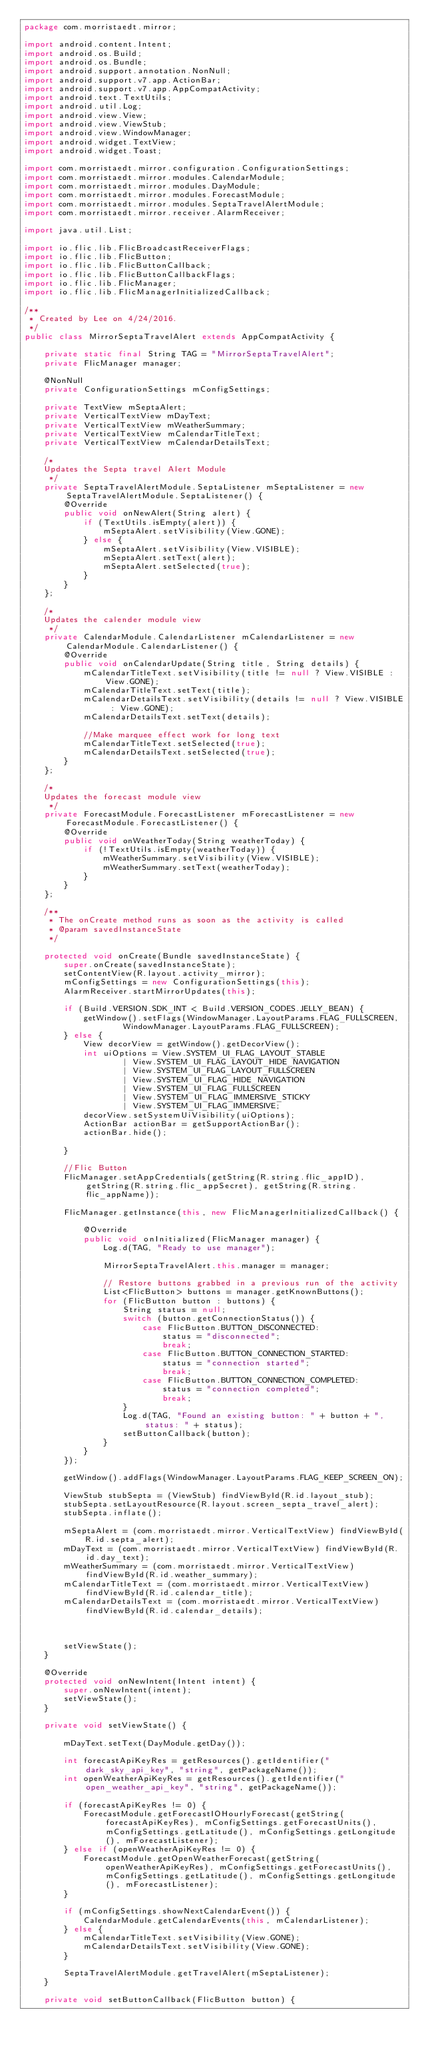Convert code to text. <code><loc_0><loc_0><loc_500><loc_500><_Java_>package com.morristaedt.mirror;

import android.content.Intent;
import android.os.Build;
import android.os.Bundle;
import android.support.annotation.NonNull;
import android.support.v7.app.ActionBar;
import android.support.v7.app.AppCompatActivity;
import android.text.TextUtils;
import android.util.Log;
import android.view.View;
import android.view.ViewStub;
import android.view.WindowManager;
import android.widget.TextView;
import android.widget.Toast;

import com.morristaedt.mirror.configuration.ConfigurationSettings;
import com.morristaedt.mirror.modules.CalendarModule;
import com.morristaedt.mirror.modules.DayModule;
import com.morristaedt.mirror.modules.ForecastModule;
import com.morristaedt.mirror.modules.SeptaTravelAlertModule;
import com.morristaedt.mirror.receiver.AlarmReceiver;

import java.util.List;

import io.flic.lib.FlicBroadcastReceiverFlags;
import io.flic.lib.FlicButton;
import io.flic.lib.FlicButtonCallback;
import io.flic.lib.FlicButtonCallbackFlags;
import io.flic.lib.FlicManager;
import io.flic.lib.FlicManagerInitializedCallback;

/**
 * Created by Lee on 4/24/2016.
 */
public class MirrorSeptaTravelAlert extends AppCompatActivity {

    private static final String TAG = "MirrorSeptaTravelAlert";
    private FlicManager manager;

    @NonNull
    private ConfigurationSettings mConfigSettings;

    private TextView mSeptaAlert;
    private VerticalTextView mDayText;
    private VerticalTextView mWeatherSummary;
    private VerticalTextView mCalendarTitleText;
    private VerticalTextView mCalendarDetailsText;

    /*
    Updates the Septa travel Alert Module
     */
    private SeptaTravelAlertModule.SeptaListener mSeptaListener = new SeptaTravelAlertModule.SeptaListener() {
        @Override
        public void onNewAlert(String alert) {
            if (TextUtils.isEmpty(alert)) {
                mSeptaAlert.setVisibility(View.GONE);
            } else {
                mSeptaAlert.setVisibility(View.VISIBLE);
                mSeptaAlert.setText(alert);
                mSeptaAlert.setSelected(true);
            }
        }
    };

    /*
    Updates the calender module view
     */
    private CalendarModule.CalendarListener mCalendarListener = new CalendarModule.CalendarListener() {
        @Override
        public void onCalendarUpdate(String title, String details) {
            mCalendarTitleText.setVisibility(title != null ? View.VISIBLE : View.GONE);
            mCalendarTitleText.setText(title);
            mCalendarDetailsText.setVisibility(details != null ? View.VISIBLE : View.GONE);
            mCalendarDetailsText.setText(details);

            //Make marquee effect work for long text
            mCalendarTitleText.setSelected(true);
            mCalendarDetailsText.setSelected(true);
        }
    };

    /*
    Updates the forecast module view
     */
    private ForecastModule.ForecastListener mForecastListener = new ForecastModule.ForecastListener() {
        @Override
        public void onWeatherToday(String weatherToday) {
            if (!TextUtils.isEmpty(weatherToday)) {
                mWeatherSummary.setVisibility(View.VISIBLE);
                mWeatherSummary.setText(weatherToday);
            }
        }
    };

    /**
     * The onCreate method runs as soon as the activity is called
     * @param savedInstanceState
     */

    protected void onCreate(Bundle savedInstanceState) {
        super.onCreate(savedInstanceState);
        setContentView(R.layout.activity_mirror);
        mConfigSettings = new ConfigurationSettings(this);
        AlarmReceiver.startMirrorUpdates(this);

        if (Build.VERSION.SDK_INT < Build.VERSION_CODES.JELLY_BEAN) {
            getWindow().setFlags(WindowManager.LayoutParams.FLAG_FULLSCREEN,
                    WindowManager.LayoutParams.FLAG_FULLSCREEN);
        } else {
            View decorView = getWindow().getDecorView();
            int uiOptions = View.SYSTEM_UI_FLAG_LAYOUT_STABLE
                    | View.SYSTEM_UI_FLAG_LAYOUT_HIDE_NAVIGATION
                    | View.SYSTEM_UI_FLAG_LAYOUT_FULLSCREEN
                    | View.SYSTEM_UI_FLAG_HIDE_NAVIGATION
                    | View.SYSTEM_UI_FLAG_FULLSCREEN
                    | View.SYSTEM_UI_FLAG_IMMERSIVE_STICKY
                    | View.SYSTEM_UI_FLAG_IMMERSIVE;
            decorView.setSystemUiVisibility(uiOptions);
            ActionBar actionBar = getSupportActionBar();
            actionBar.hide();

        }

        //Flic Button
        FlicManager.setAppCredentials(getString(R.string.flic_appID), getString(R.string.flic_appSecret), getString(R.string.flic_appName));

        FlicManager.getInstance(this, new FlicManagerInitializedCallback() {

            @Override
            public void onInitialized(FlicManager manager) {
                Log.d(TAG, "Ready to use manager");

                MirrorSeptaTravelAlert.this.manager = manager;

                // Restore buttons grabbed in a previous run of the activity
                List<FlicButton> buttons = manager.getKnownButtons();
                for (FlicButton button : buttons) {
                    String status = null;
                    switch (button.getConnectionStatus()) {
                        case FlicButton.BUTTON_DISCONNECTED:
                            status = "disconnected";
                            break;
                        case FlicButton.BUTTON_CONNECTION_STARTED:
                            status = "connection started";
                            break;
                        case FlicButton.BUTTON_CONNECTION_COMPLETED:
                            status = "connection completed";
                            break;
                    }
                    Log.d(TAG, "Found an existing button: " + button + ", status: " + status);
                    setButtonCallback(button);
                }
            }
        });

        getWindow().addFlags(WindowManager.LayoutParams.FLAG_KEEP_SCREEN_ON);

        ViewStub stubSepta = (ViewStub) findViewById(R.id.layout_stub);
        stubSepta.setLayoutResource(R.layout.screen_septa_travel_alert);
        stubSepta.inflate();

        mSeptaAlert = (com.morristaedt.mirror.VerticalTextView) findViewById(R.id.septa_alert);
        mDayText = (com.morristaedt.mirror.VerticalTextView) findViewById(R.id.day_text);
        mWeatherSummary = (com.morristaedt.mirror.VerticalTextView) findViewById(R.id.weather_summary);
        mCalendarTitleText = (com.morristaedt.mirror.VerticalTextView) findViewById(R.id.calendar_title);
        mCalendarDetailsText = (com.morristaedt.mirror.VerticalTextView) findViewById(R.id.calendar_details);



        setViewState();
    }

    @Override
    protected void onNewIntent(Intent intent) {
        super.onNewIntent(intent);
        setViewState();
    }

    private void setViewState() {

        mDayText.setText(DayModule.getDay());

        int forecastApiKeyRes = getResources().getIdentifier("dark_sky_api_key", "string", getPackageName());
        int openWeatherApiKeyRes = getResources().getIdentifier("open_weather_api_key", "string", getPackageName());

        if (forecastApiKeyRes != 0) {
            ForecastModule.getForecastIOHourlyForecast(getString(forecastApiKeyRes), mConfigSettings.getForecastUnits(), mConfigSettings.getLatitude(), mConfigSettings.getLongitude(), mForecastListener);
        } else if (openWeatherApiKeyRes != 0) {
            ForecastModule.getOpenWeatherForecast(getString(openWeatherApiKeyRes), mConfigSettings.getForecastUnits(), mConfigSettings.getLatitude(), mConfigSettings.getLongitude(), mForecastListener);
        }

        if (mConfigSettings.showNextCalendarEvent()) {
            CalendarModule.getCalendarEvents(this, mCalendarListener);
        } else {
            mCalendarTitleText.setVisibility(View.GONE);
            mCalendarDetailsText.setVisibility(View.GONE);
        }

        SeptaTravelAlertModule.getTravelAlert(mSeptaListener);
    }

    private void setButtonCallback(FlicButton button) {</code> 